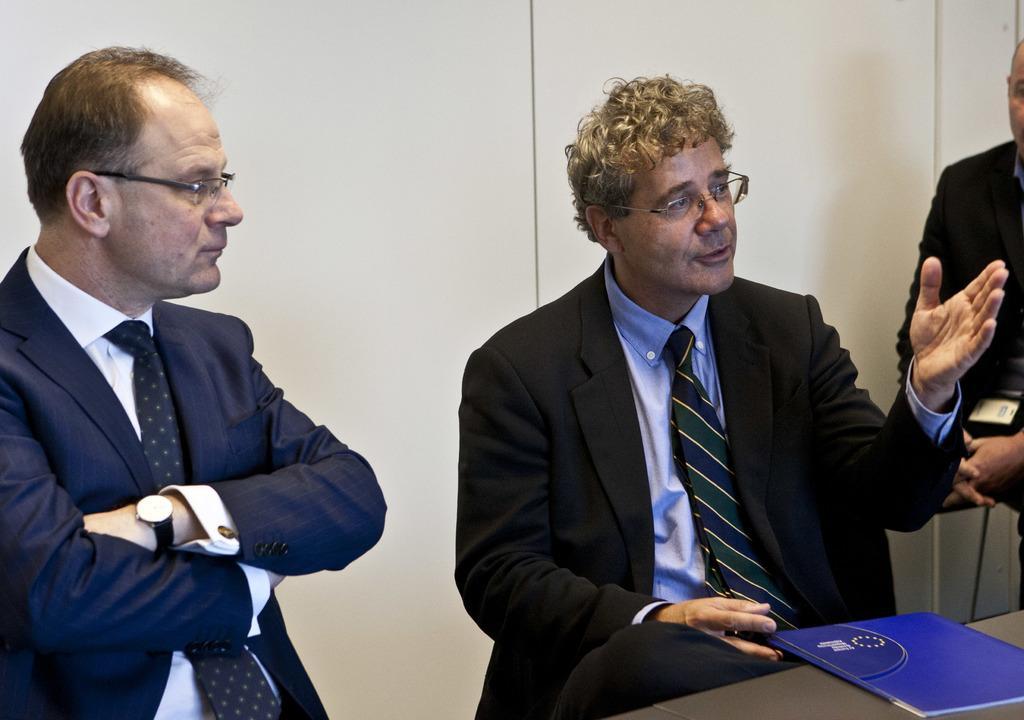Can you describe this image briefly? In this image we can see persons sitting on the chairs at the table. On the table we can see book. In the background there is wall. 